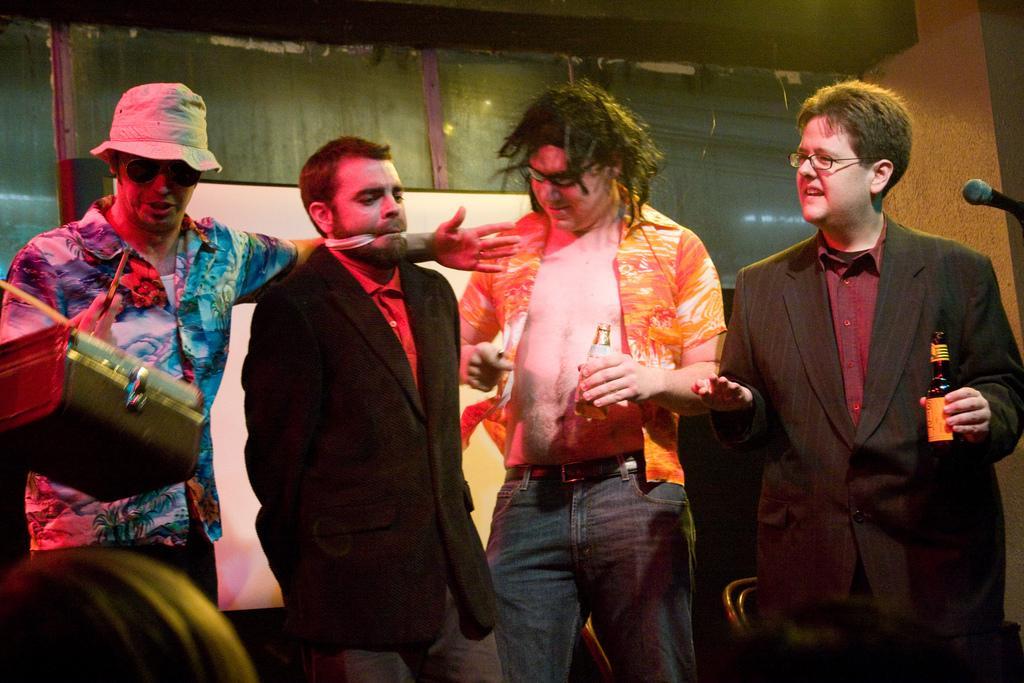Describe this image in one or two sentences. In this picture we can see four people where two are holding bottles with their hands, chairs, mic, cap and in the background we can see the wall. 